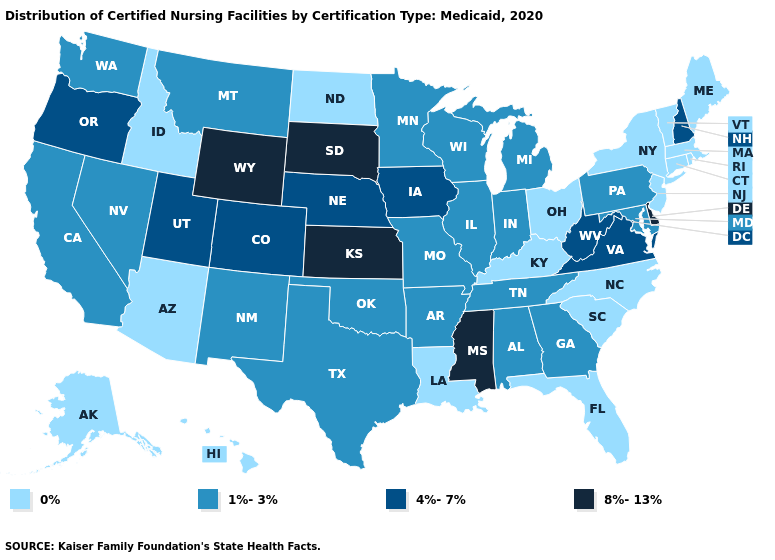Does New Hampshire have the lowest value in the Northeast?
Concise answer only. No. What is the value of Nevada?
Give a very brief answer. 1%-3%. What is the value of Massachusetts?
Answer briefly. 0%. Name the states that have a value in the range 1%-3%?
Short answer required. Alabama, Arkansas, California, Georgia, Illinois, Indiana, Maryland, Michigan, Minnesota, Missouri, Montana, Nevada, New Mexico, Oklahoma, Pennsylvania, Tennessee, Texas, Washington, Wisconsin. Name the states that have a value in the range 8%-13%?
Give a very brief answer. Delaware, Kansas, Mississippi, South Dakota, Wyoming. Name the states that have a value in the range 1%-3%?
Give a very brief answer. Alabama, Arkansas, California, Georgia, Illinois, Indiana, Maryland, Michigan, Minnesota, Missouri, Montana, Nevada, New Mexico, Oklahoma, Pennsylvania, Tennessee, Texas, Washington, Wisconsin. What is the highest value in the USA?
Give a very brief answer. 8%-13%. Name the states that have a value in the range 8%-13%?
Keep it brief. Delaware, Kansas, Mississippi, South Dakota, Wyoming. What is the lowest value in states that border Texas?
Keep it brief. 0%. Does Missouri have the same value as New York?
Answer briefly. No. Name the states that have a value in the range 4%-7%?
Give a very brief answer. Colorado, Iowa, Nebraska, New Hampshire, Oregon, Utah, Virginia, West Virginia. Among the states that border Vermont , does Massachusetts have the lowest value?
Answer briefly. Yes. What is the lowest value in the USA?
Keep it brief. 0%. 